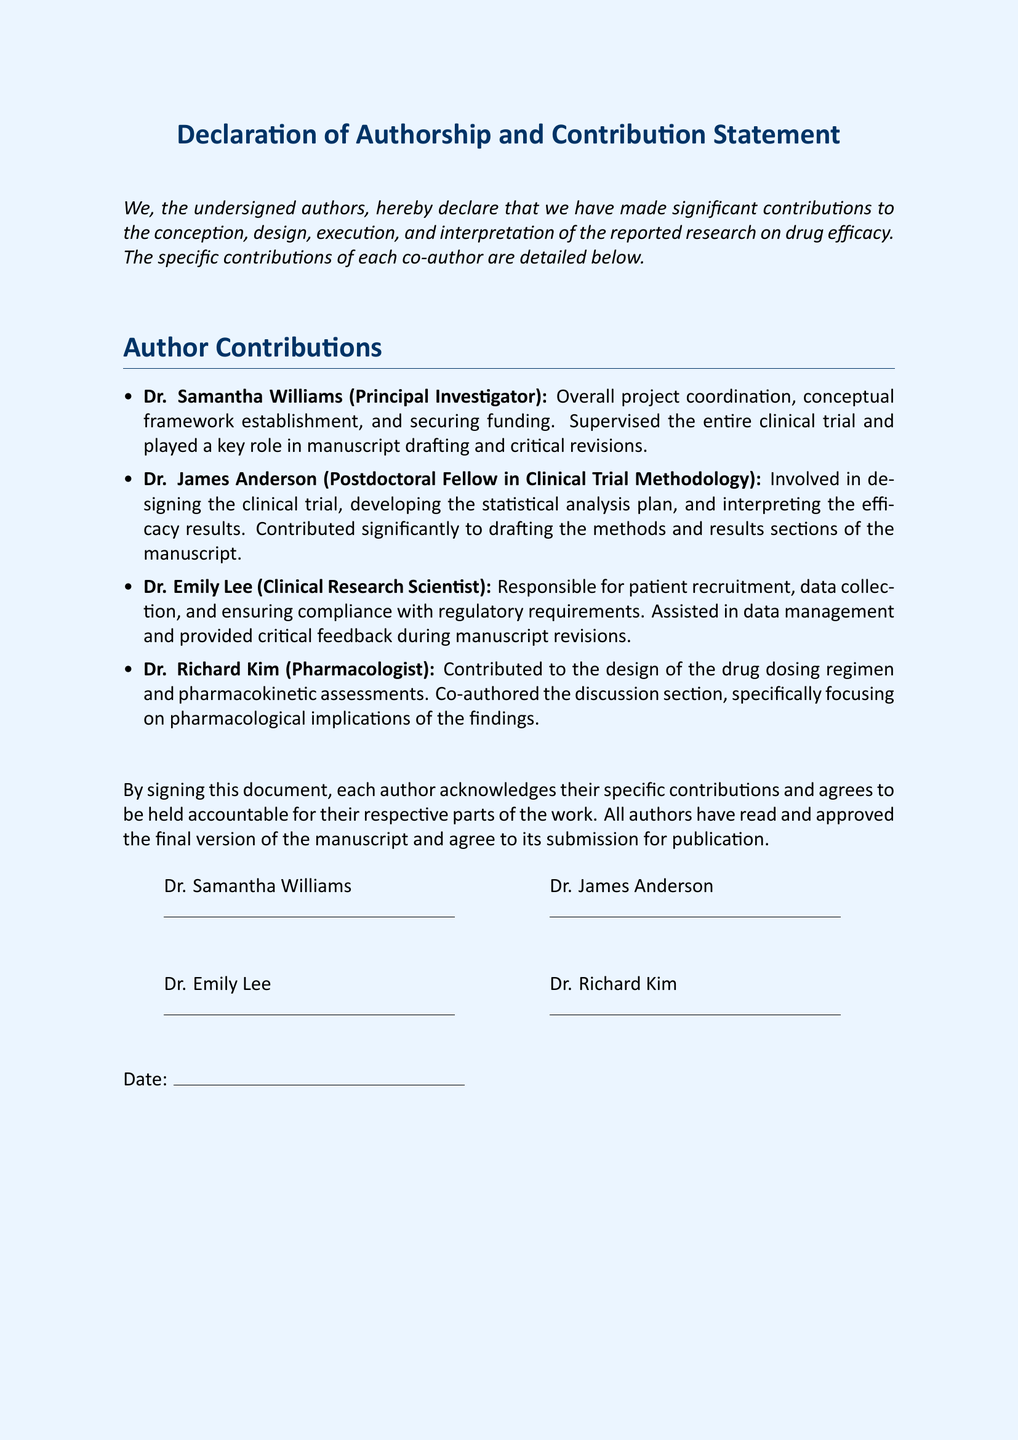What is the title of the document? The title is stated at the top of the document and identifies the overall subject.
Answer: Declaration of Authorship and Contribution Statement Who is the Principal Investigator? The document specifies the name of the person responsible for the overall project coordination.
Answer: Dr. Samantha Williams What type of research is reported in the document? The text indicates the focus of the research conducted by the authors.
Answer: drug efficacy Who contributed to patient recruitment? The document mentions specific responsibilities assigned to each author.
Answer: Dr. Emily Lee How many authors signed the declaration? The document lists the authors involved in the research and their contributions.
Answer: Four What was Dr. James Anderson's main role? The document outlines the specific contributions made by Dr. James Anderson.
Answer: designing the clinical trial What does each author agree to by signing the document? The text explains the significance of signing and its implications for the authors' accountability.
Answer: be held accountable What section of the manuscript did Dr. Richard Kim co-author? The document points to specific sections of the manuscript where individual contributions were made.
Answer: discussion section When was the document signed? The document has a section where a date is to be entered for when the declaration is finalized.
Answer: (not specified in the document) 